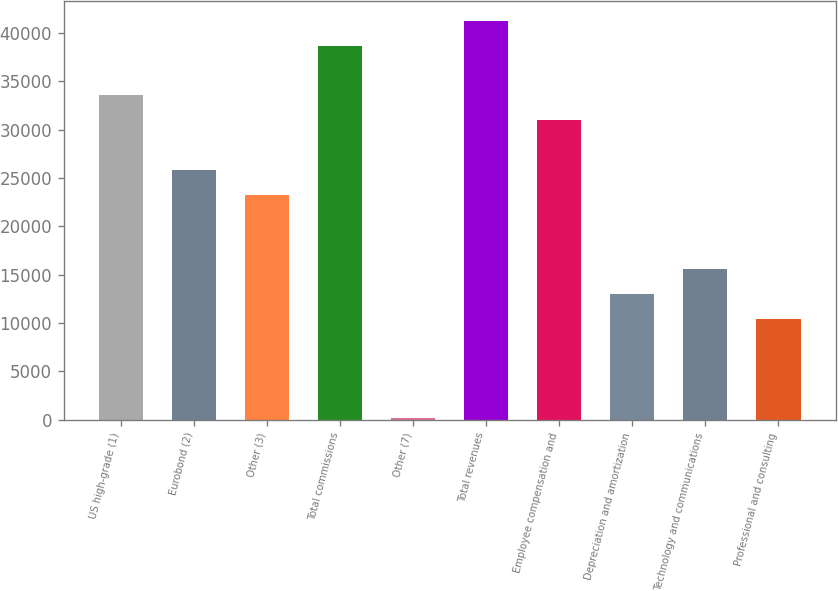Convert chart to OTSL. <chart><loc_0><loc_0><loc_500><loc_500><bar_chart><fcel>US high-grade (1)<fcel>Eurobond (2)<fcel>Other (3)<fcel>Total commissions<fcel>Other (7)<fcel>Total revenues<fcel>Employee compensation and<fcel>Depreciation and amortization<fcel>Technology and communications<fcel>Professional and consulting<nl><fcel>33538.2<fcel>25839<fcel>23272.6<fcel>38671<fcel>175<fcel>41237.4<fcel>30971.8<fcel>13007<fcel>15573.4<fcel>10440.6<nl></chart> 